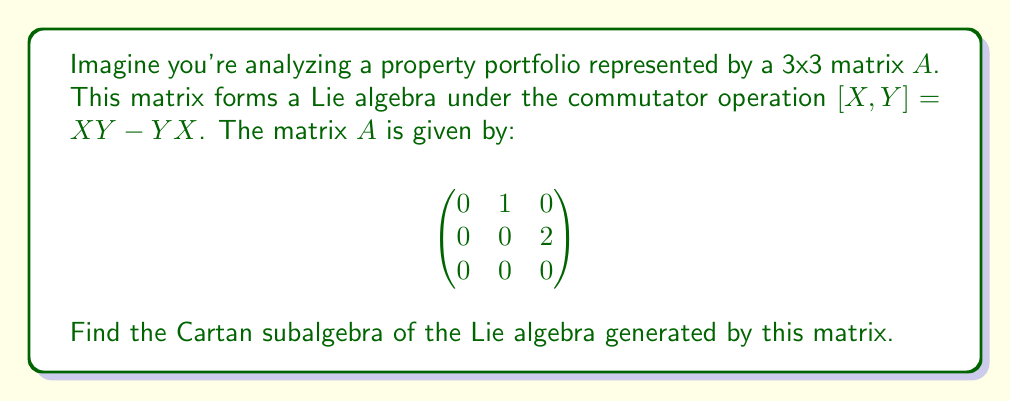Can you solve this math problem? Let's approach this step-by-step:

1) First, recall that a Cartan subalgebra is a maximal abelian subalgebra consisting of semisimple elements.

2) In this case, we're dealing with a nilpotent Lie algebra. For nilpotent Lie algebras, the Cartan subalgebra is the center of the algebra.

3) The center of a Lie algebra consists of all elements that commute with every element in the algebra.

4) Let's consider a general element of our Lie algebra:

   $$X = \begin{pmatrix}
   0 & a & b \\
   0 & 0 & 2a \\
   0 & 0 & 0
   \end{pmatrix}$$

   where $a$ and $b$ are real numbers.

5) Now, let's find which elements commute with all others. An element $Y$ in the center must satisfy $[X,Y] = 0$ for all $X$.

6) Let $Y = \begin{pmatrix}
   0 & c & d \\
   0 & 0 & 2c \\
   0 & 0 & 0
   \end{pmatrix}$

7) Computing the commutator:

   $$[X,Y] = XY - YX = \begin{pmatrix}
   0 & 0 & 2ac-2ac \\
   0 & 0 & 0 \\
   0 & 0 & 0
   \end{pmatrix} = 0$$

8) This is always zero, regardless of the values of $a$, $b$, $c$, and $d$.

9) Therefore, every element in our Lie algebra commutes with every other element.

10) This means that the entire Lie algebra is its own Cartan subalgebra.
Answer: The Cartan subalgebra is the entire Lie algebra generated by $A$, which consists of all matrices of the form:

$$\begin{pmatrix}
0 & x & y \\
0 & 0 & 2x \\
0 & 0 & 0
\end{pmatrix}$$

where $x$ and $y$ are real numbers. 